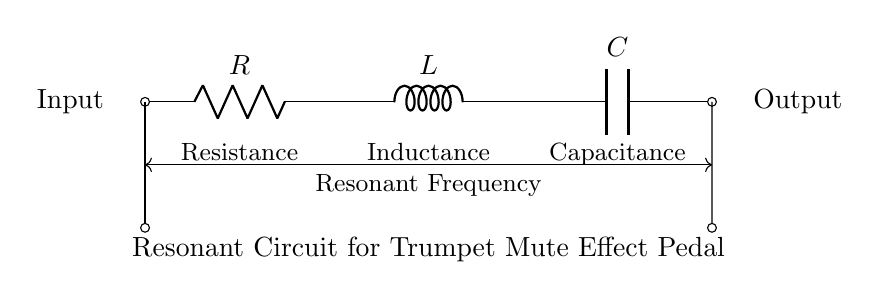What three components are present in this circuit? The circuit diagram contains three components: a resistor, an inductor, and a capacitor. These are the key components in an RLC circuit.
Answer: Resistor, Inductor, Capacitor What does the arrow near the output indicate? The arrow indicates the output of the circuit. It signifies where the output signal can be accessed after processing through the RLC components.
Answer: Output What is the purpose of this circuit? This circuit is designed to create a mute effect for trumpet sound, which alters the tonal quality by using resonant frequency manipulation.
Answer: Trumpet mute effect How are the components connected in the circuit? The components are connected in series, as depicted by the lines connecting the resistor to the inductor and then to the capacitor, forming a continuous path for current.
Answer: Series What is the relationship between the resonant frequency and the components? The resonant frequency in an RLC circuit is determined by the values of resistance, inductance, and capacitance, following the formula resonant frequency equals one divided by two pi times the square root of inductance times capacitance.
Answer: Resonant frequency function of RLC Which component would primarily affect the frequency response of the circuit? The inductor primarily affects the frequency response, as it interacts with the capacitor's capacitance to define the resonant frequency of the circuit's response to input signals.
Answer: Inductor 